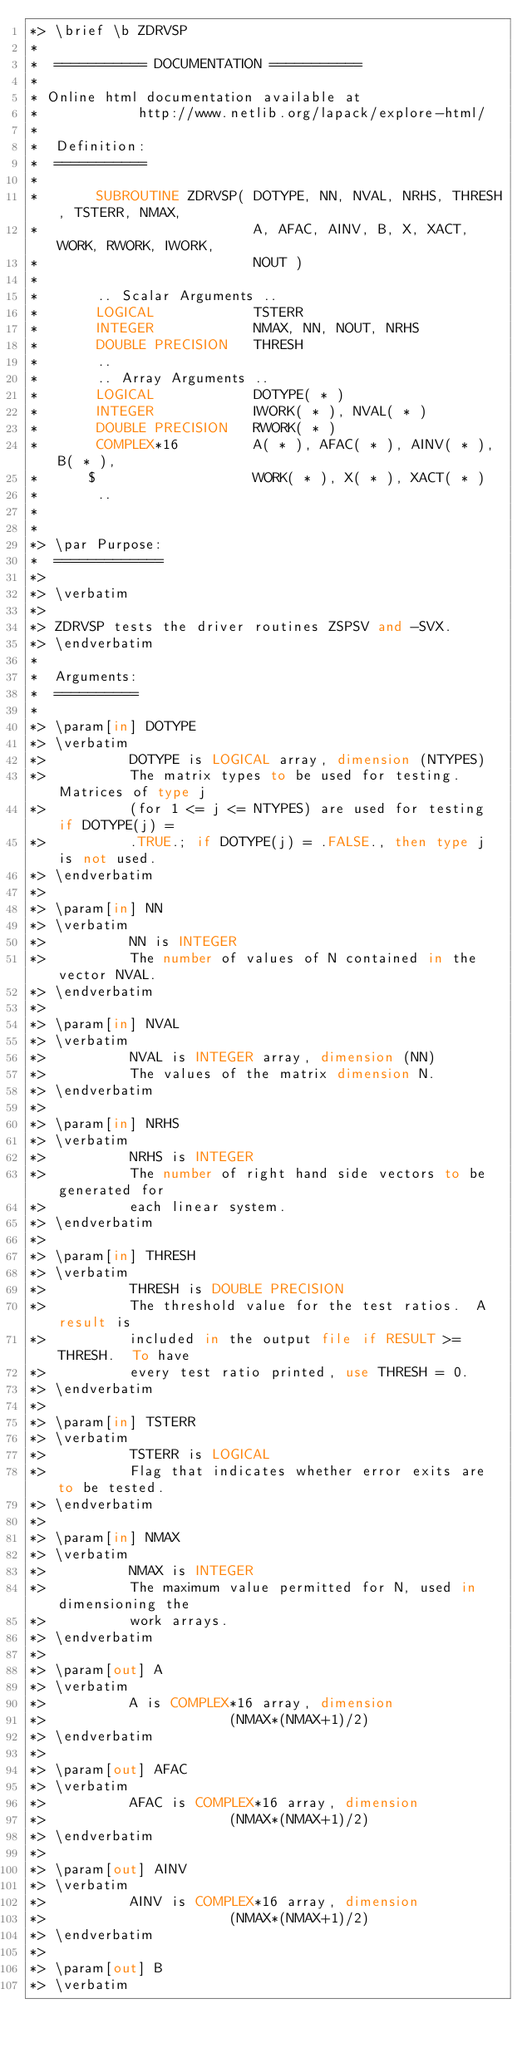<code> <loc_0><loc_0><loc_500><loc_500><_FORTRAN_>*> \brief \b ZDRVSP
*
*  =========== DOCUMENTATION ===========
*
* Online html documentation available at 
*            http://www.netlib.org/lapack/explore-html/ 
*
*  Definition:
*  ===========
*
*       SUBROUTINE ZDRVSP( DOTYPE, NN, NVAL, NRHS, THRESH, TSTERR, NMAX,
*                          A, AFAC, AINV, B, X, XACT, WORK, RWORK, IWORK,
*                          NOUT )
* 
*       .. Scalar Arguments ..
*       LOGICAL            TSTERR
*       INTEGER            NMAX, NN, NOUT, NRHS
*       DOUBLE PRECISION   THRESH
*       ..
*       .. Array Arguments ..
*       LOGICAL            DOTYPE( * )
*       INTEGER            IWORK( * ), NVAL( * )
*       DOUBLE PRECISION   RWORK( * )
*       COMPLEX*16         A( * ), AFAC( * ), AINV( * ), B( * ),
*      $                   WORK( * ), X( * ), XACT( * )
*       ..
*  
*
*> \par Purpose:
*  =============
*>
*> \verbatim
*>
*> ZDRVSP tests the driver routines ZSPSV and -SVX.
*> \endverbatim
*
*  Arguments:
*  ==========
*
*> \param[in] DOTYPE
*> \verbatim
*>          DOTYPE is LOGICAL array, dimension (NTYPES)
*>          The matrix types to be used for testing.  Matrices of type j
*>          (for 1 <= j <= NTYPES) are used for testing if DOTYPE(j) =
*>          .TRUE.; if DOTYPE(j) = .FALSE., then type j is not used.
*> \endverbatim
*>
*> \param[in] NN
*> \verbatim
*>          NN is INTEGER
*>          The number of values of N contained in the vector NVAL.
*> \endverbatim
*>
*> \param[in] NVAL
*> \verbatim
*>          NVAL is INTEGER array, dimension (NN)
*>          The values of the matrix dimension N.
*> \endverbatim
*>
*> \param[in] NRHS
*> \verbatim
*>          NRHS is INTEGER
*>          The number of right hand side vectors to be generated for
*>          each linear system.
*> \endverbatim
*>
*> \param[in] THRESH
*> \verbatim
*>          THRESH is DOUBLE PRECISION
*>          The threshold value for the test ratios.  A result is
*>          included in the output file if RESULT >= THRESH.  To have
*>          every test ratio printed, use THRESH = 0.
*> \endverbatim
*>
*> \param[in] TSTERR
*> \verbatim
*>          TSTERR is LOGICAL
*>          Flag that indicates whether error exits are to be tested.
*> \endverbatim
*>
*> \param[in] NMAX
*> \verbatim
*>          NMAX is INTEGER
*>          The maximum value permitted for N, used in dimensioning the
*>          work arrays.
*> \endverbatim
*>
*> \param[out] A
*> \verbatim
*>          A is COMPLEX*16 array, dimension
*>                      (NMAX*(NMAX+1)/2)
*> \endverbatim
*>
*> \param[out] AFAC
*> \verbatim
*>          AFAC is COMPLEX*16 array, dimension
*>                      (NMAX*(NMAX+1)/2)
*> \endverbatim
*>
*> \param[out] AINV
*> \verbatim
*>          AINV is COMPLEX*16 array, dimension
*>                      (NMAX*(NMAX+1)/2)
*> \endverbatim
*>
*> \param[out] B
*> \verbatim</code> 